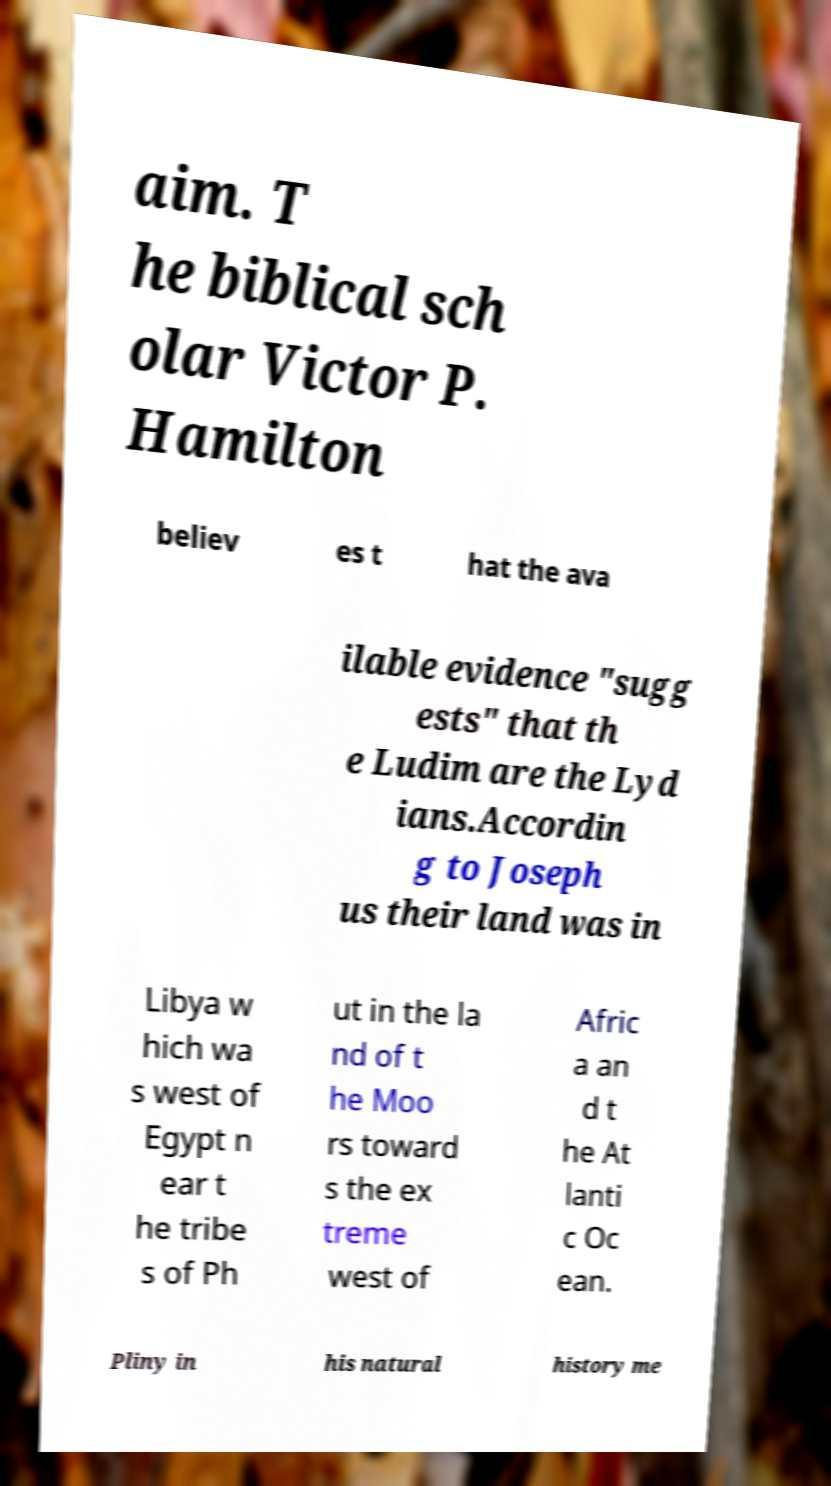I need the written content from this picture converted into text. Can you do that? aim. T he biblical sch olar Victor P. Hamilton believ es t hat the ava ilable evidence "sugg ests" that th e Ludim are the Lyd ians.Accordin g to Joseph us their land was in Libya w hich wa s west of Egypt n ear t he tribe s of Ph ut in the la nd of t he Moo rs toward s the ex treme west of Afric a an d t he At lanti c Oc ean. Pliny in his natural history me 